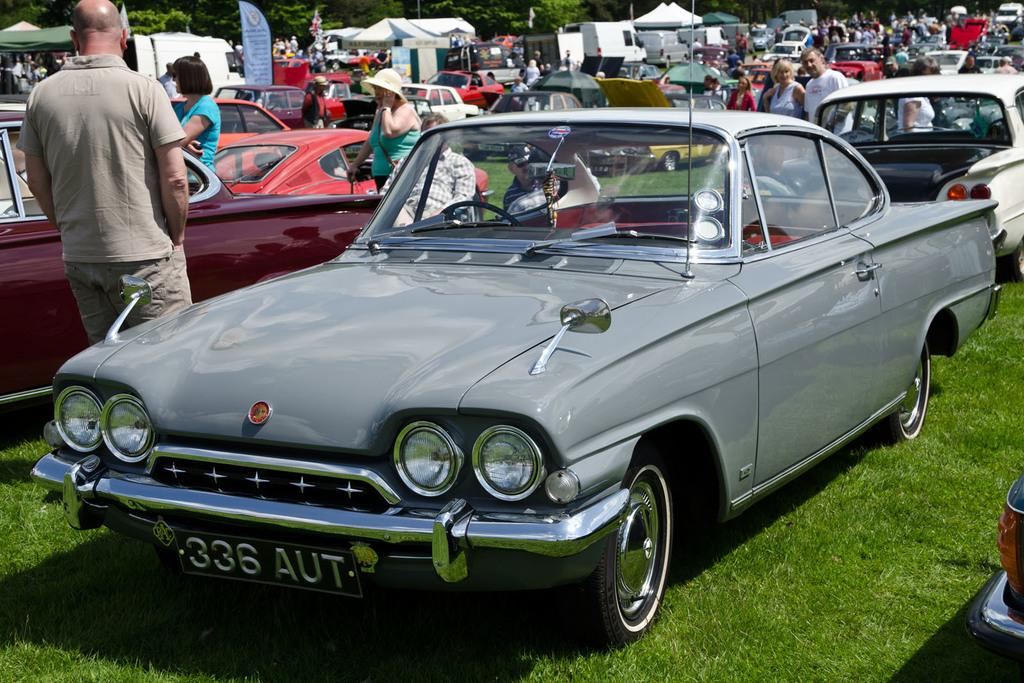What is on the ground in the image? There is a car on the ground in the image. Who is standing beside the car? A person is standing beside the car. How many people are standing in the image? There is a group of people standing in the image. What can be seen in the background of the image? Trees are visible at the back of the image. What type of scale is being used to weigh the car in the image? There is no scale present in the image, and the car is not being weighed. 